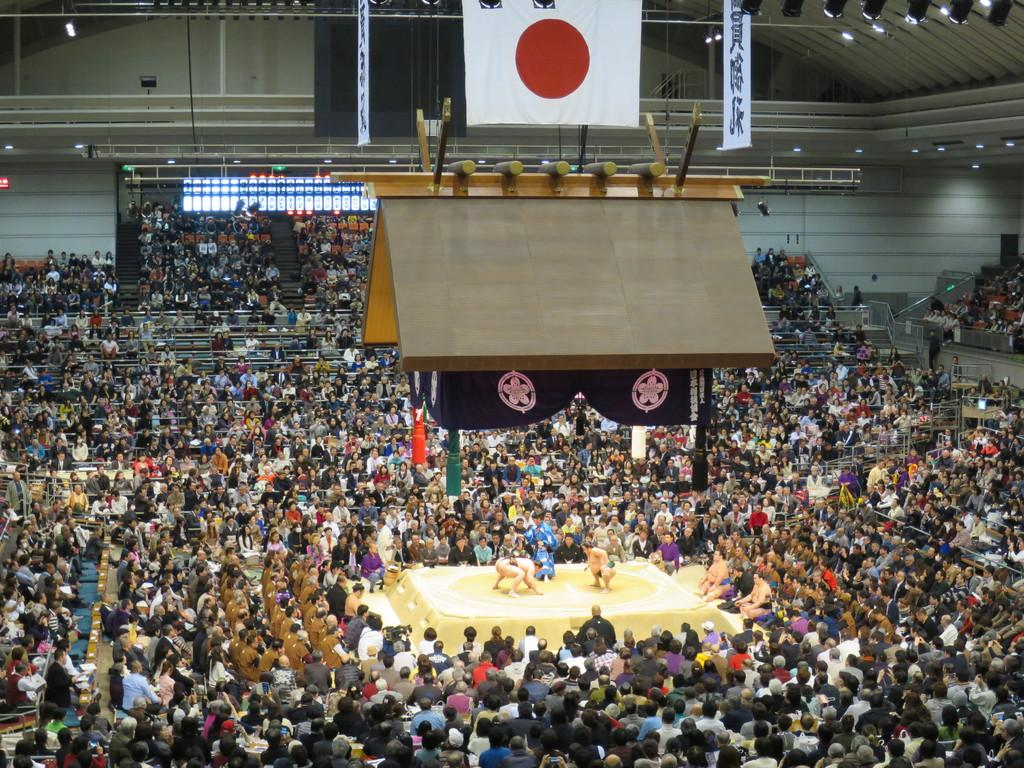What are the two people in the center of the image doing? The two people are wrestling in the center of the image. What can be seen in the background of the image? There is a wall in the background of the image. What is present at the top of the image? There is a board and a flag at the top of the image. What can be seen illuminated in the image? There are lights visible in the image. How many beds are visible in the image? There are no beds visible in the image. What type of boundary is present in the image? There is no boundary present in the image. 